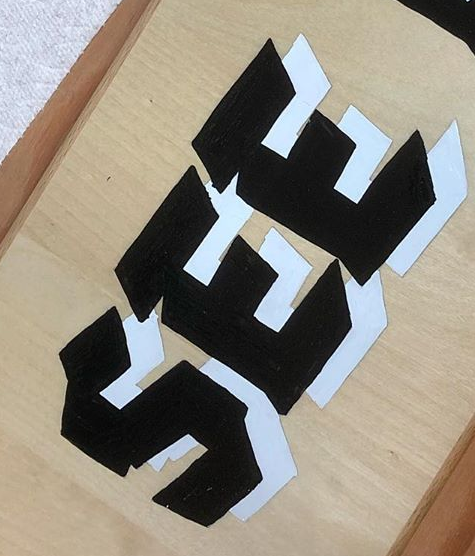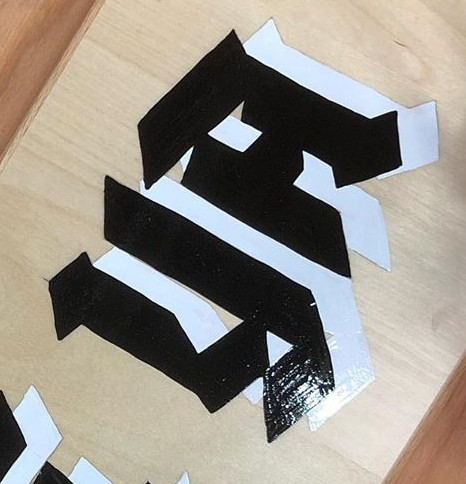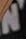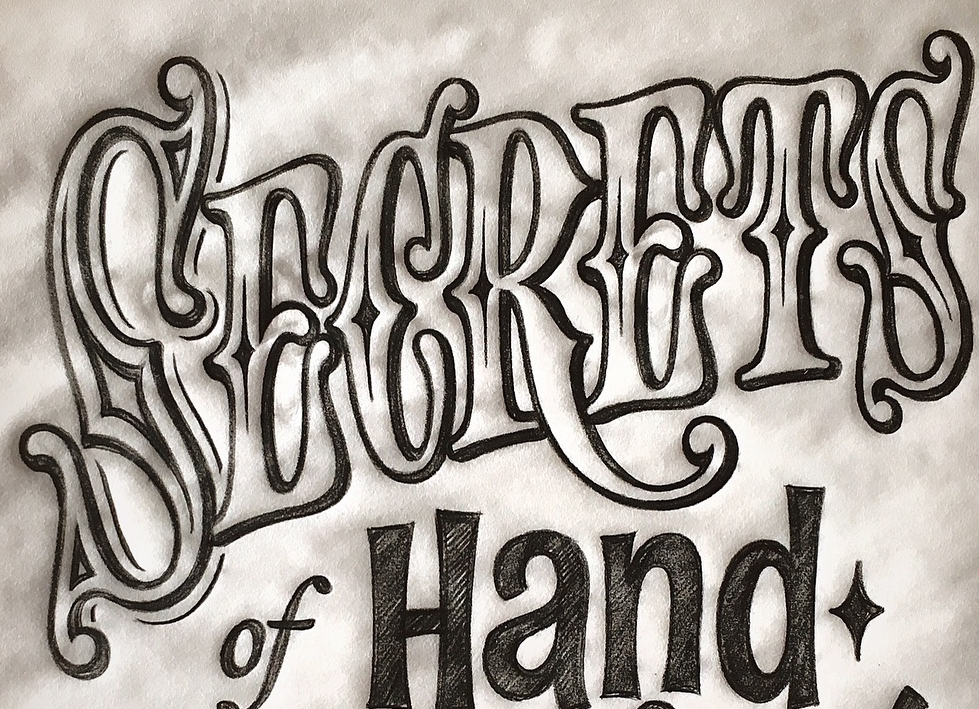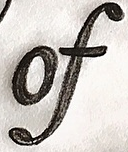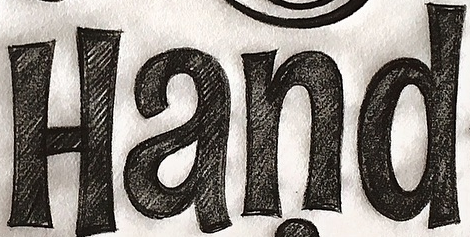What words are shown in these images in order, separated by a semicolon? SEE; YA; N; SECRETS; of; Hand 